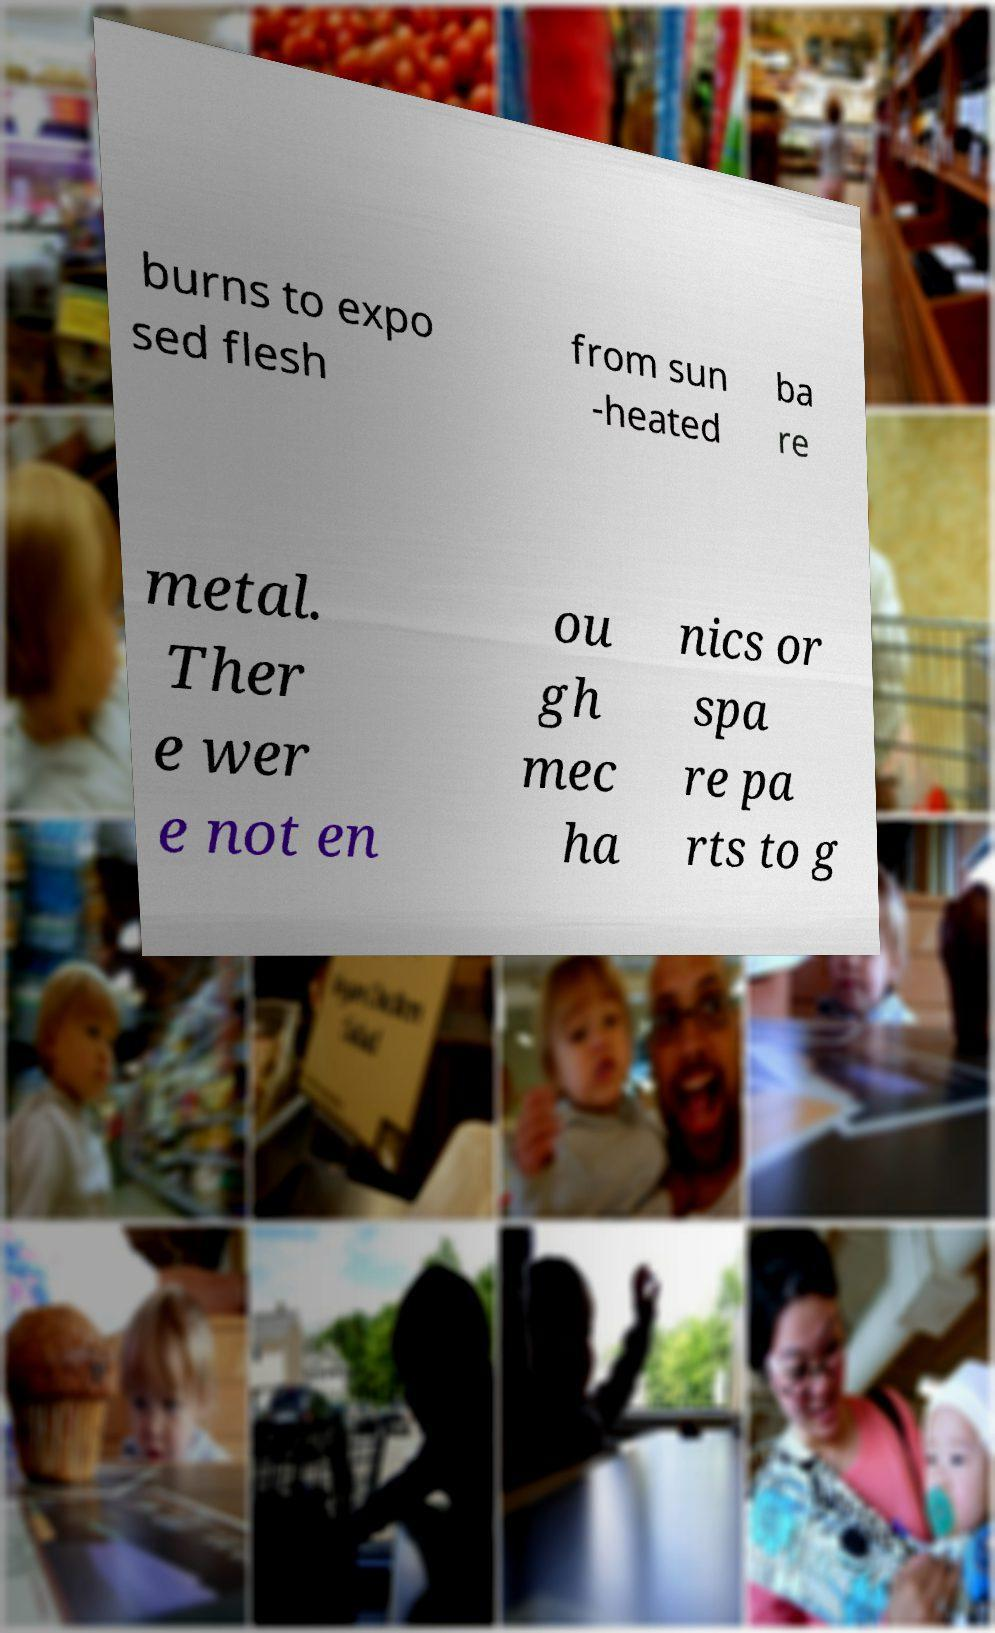For documentation purposes, I need the text within this image transcribed. Could you provide that? burns to expo sed flesh from sun -heated ba re metal. Ther e wer e not en ou gh mec ha nics or spa re pa rts to g 